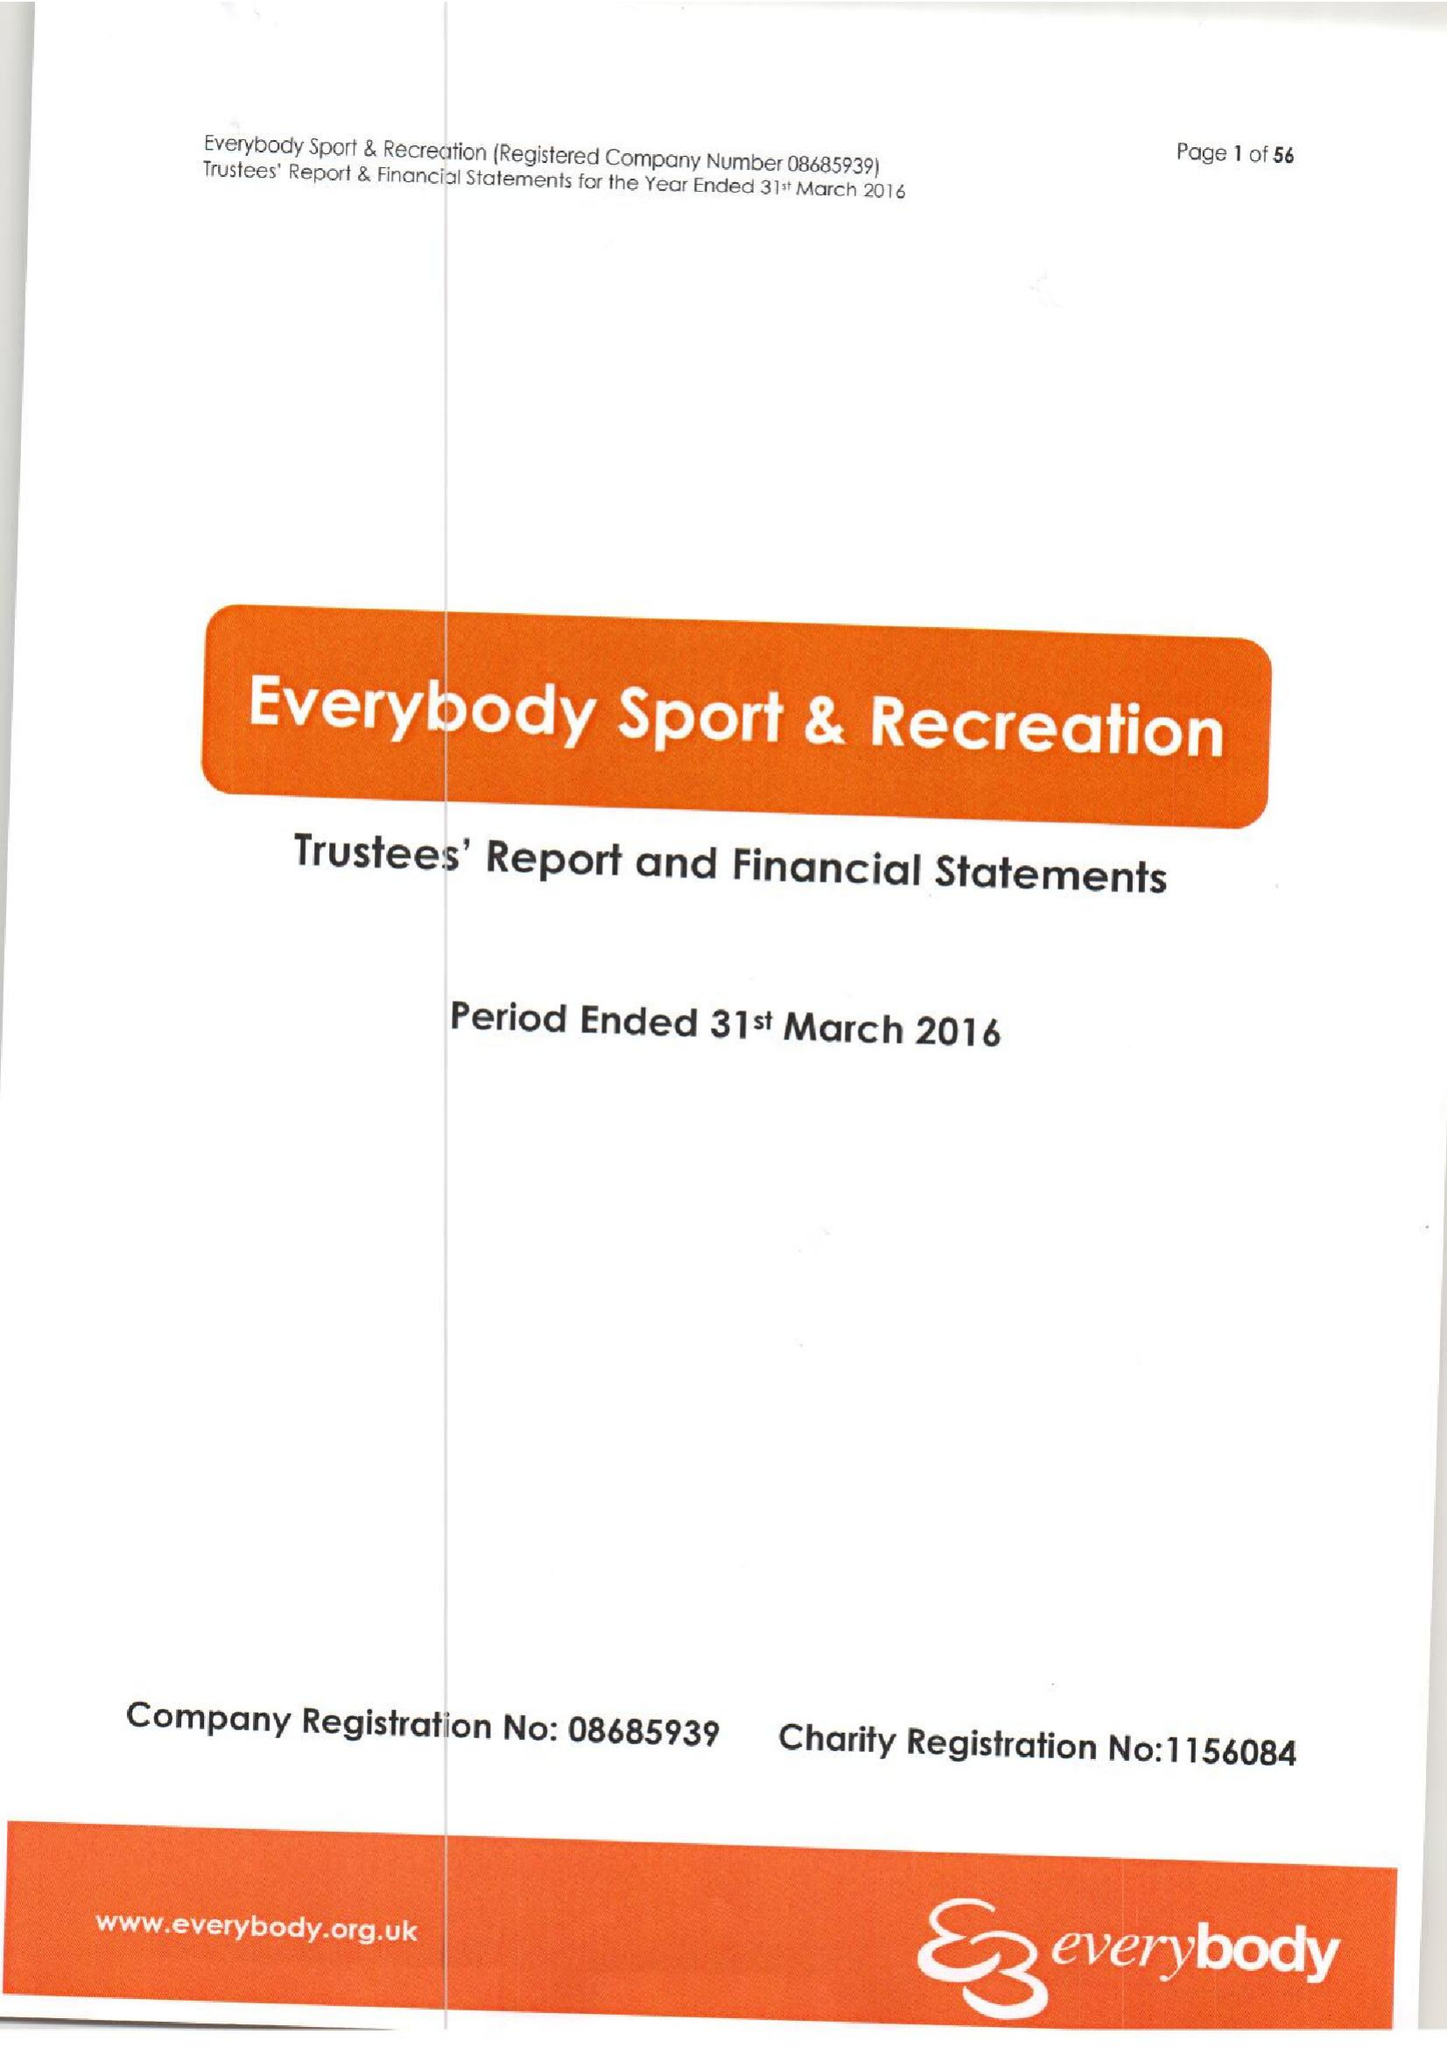What is the value for the charity_name?
Answer the question using a single word or phrase. Everybody Sport and Recreation 